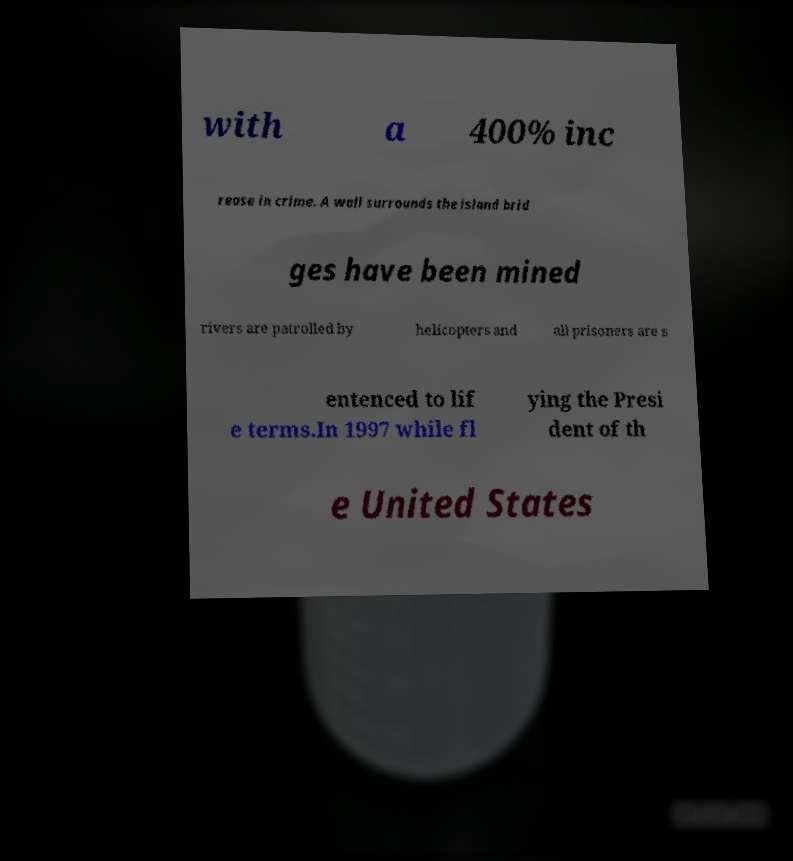There's text embedded in this image that I need extracted. Can you transcribe it verbatim? with a 400% inc rease in crime. A wall surrounds the island brid ges have been mined rivers are patrolled by helicopters and all prisoners are s entenced to lif e terms.In 1997 while fl ying the Presi dent of th e United States 